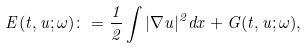<formula> <loc_0><loc_0><loc_500><loc_500>E ( t , u ; \omega ) \colon = \frac { 1 } { 2 } \int | \nabla u | ^ { 2 } d x + G ( t , u ; \omega ) ,</formula> 